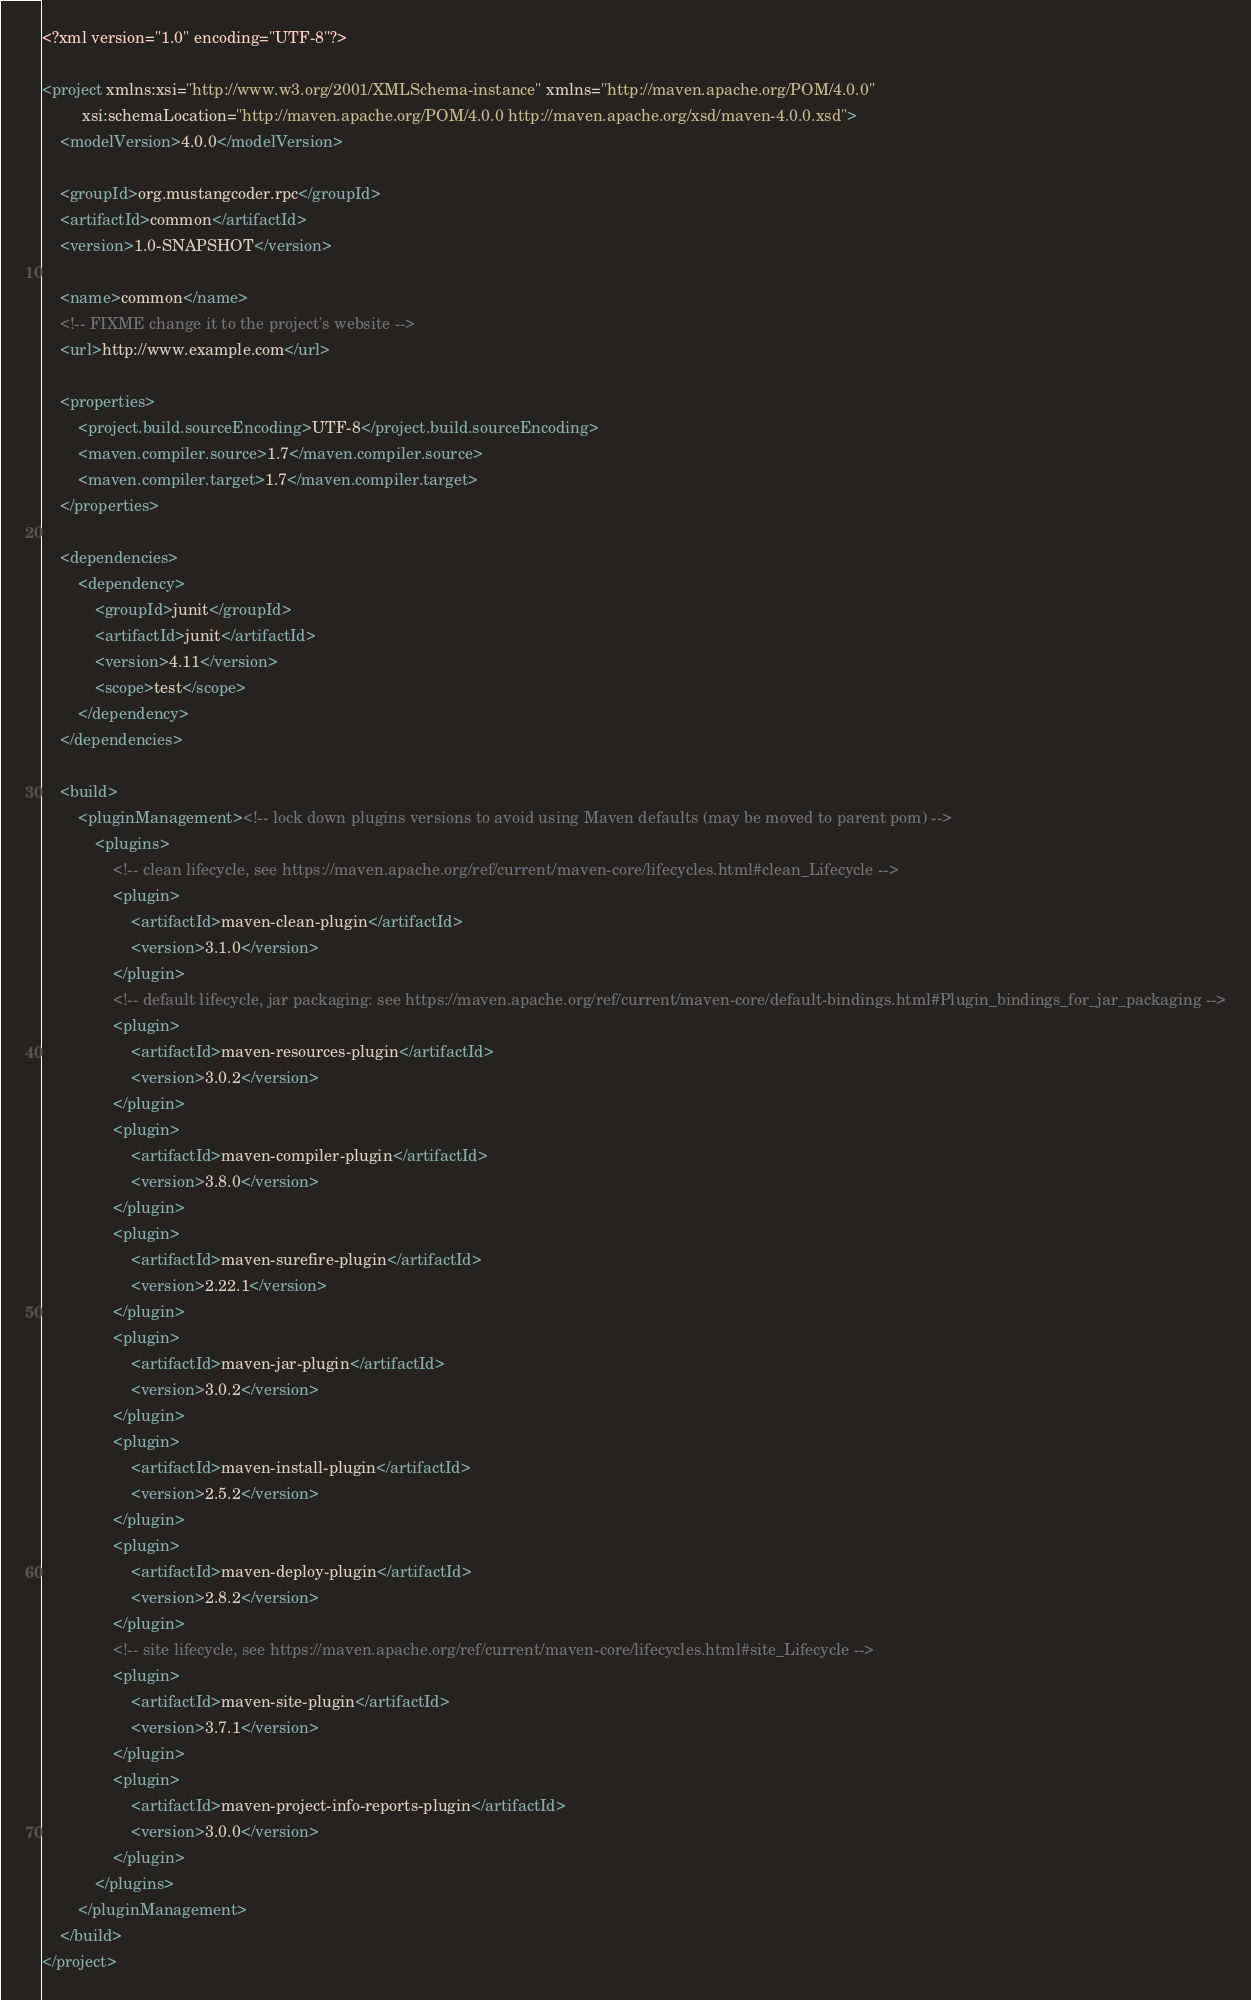Convert code to text. <code><loc_0><loc_0><loc_500><loc_500><_XML_><?xml version="1.0" encoding="UTF-8"?>

<project xmlns:xsi="http://www.w3.org/2001/XMLSchema-instance" xmlns="http://maven.apache.org/POM/4.0.0"
         xsi:schemaLocation="http://maven.apache.org/POM/4.0.0 http://maven.apache.org/xsd/maven-4.0.0.xsd">
    <modelVersion>4.0.0</modelVersion>

    <groupId>org.mustangcoder.rpc</groupId>
    <artifactId>common</artifactId>
    <version>1.0-SNAPSHOT</version>

    <name>common</name>
    <!-- FIXME change it to the project's website -->
    <url>http://www.example.com</url>

    <properties>
        <project.build.sourceEncoding>UTF-8</project.build.sourceEncoding>
        <maven.compiler.source>1.7</maven.compiler.source>
        <maven.compiler.target>1.7</maven.compiler.target>
    </properties>

    <dependencies>
        <dependency>
            <groupId>junit</groupId>
            <artifactId>junit</artifactId>
            <version>4.11</version>
            <scope>test</scope>
        </dependency>
    </dependencies>

    <build>
        <pluginManagement><!-- lock down plugins versions to avoid using Maven defaults (may be moved to parent pom) -->
            <plugins>
                <!-- clean lifecycle, see https://maven.apache.org/ref/current/maven-core/lifecycles.html#clean_Lifecycle -->
                <plugin>
                    <artifactId>maven-clean-plugin</artifactId>
                    <version>3.1.0</version>
                </plugin>
                <!-- default lifecycle, jar packaging: see https://maven.apache.org/ref/current/maven-core/default-bindings.html#Plugin_bindings_for_jar_packaging -->
                <plugin>
                    <artifactId>maven-resources-plugin</artifactId>
                    <version>3.0.2</version>
                </plugin>
                <plugin>
                    <artifactId>maven-compiler-plugin</artifactId>
                    <version>3.8.0</version>
                </plugin>
                <plugin>
                    <artifactId>maven-surefire-plugin</artifactId>
                    <version>2.22.1</version>
                </plugin>
                <plugin>
                    <artifactId>maven-jar-plugin</artifactId>
                    <version>3.0.2</version>
                </plugin>
                <plugin>
                    <artifactId>maven-install-plugin</artifactId>
                    <version>2.5.2</version>
                </plugin>
                <plugin>
                    <artifactId>maven-deploy-plugin</artifactId>
                    <version>2.8.2</version>
                </plugin>
                <!-- site lifecycle, see https://maven.apache.org/ref/current/maven-core/lifecycles.html#site_Lifecycle -->
                <plugin>
                    <artifactId>maven-site-plugin</artifactId>
                    <version>3.7.1</version>
                </plugin>
                <plugin>
                    <artifactId>maven-project-info-reports-plugin</artifactId>
                    <version>3.0.0</version>
                </plugin>
            </plugins>
        </pluginManagement>
    </build>
</project>
</code> 